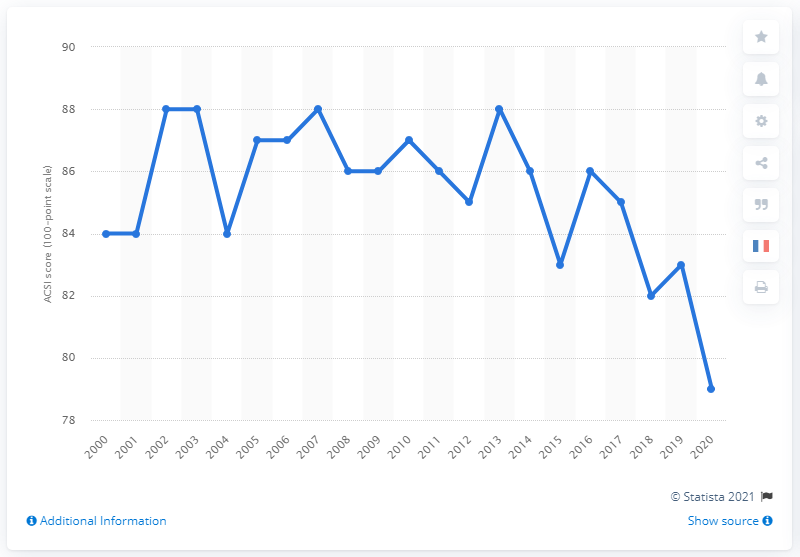Point out several critical features in this image. In 2020, Amazon's customer satisfaction score was 79%. 